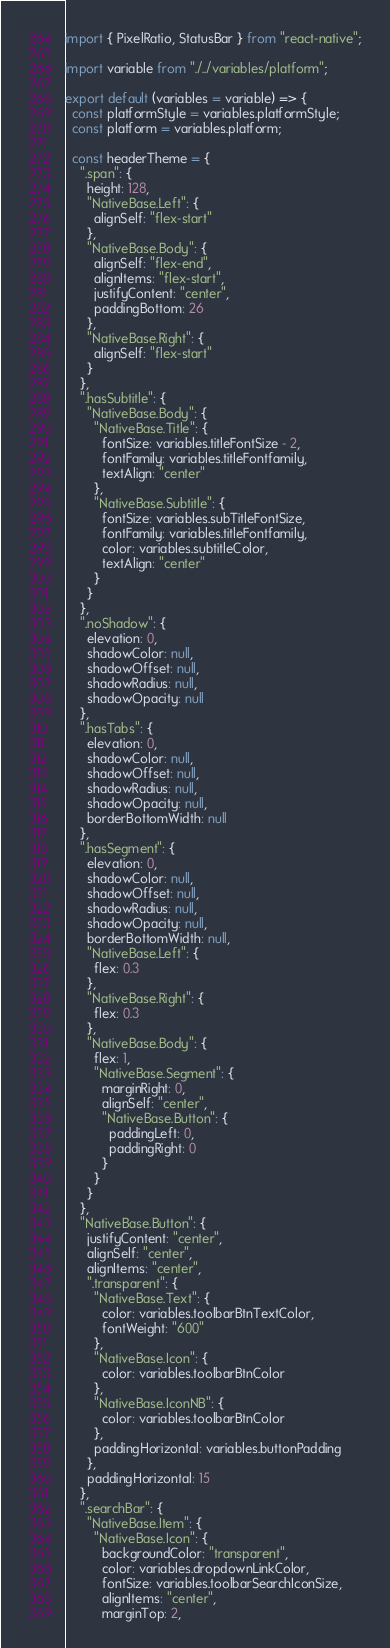Convert code to text. <code><loc_0><loc_0><loc_500><loc_500><_JavaScript_>import { PixelRatio, StatusBar } from "react-native";

import variable from "./../variables/platform";

export default (variables = variable) => {
  const platformStyle = variables.platformStyle;
  const platform = variables.platform;

  const headerTheme = {
    ".span": {
      height: 128,
      "NativeBase.Left": {
        alignSelf: "flex-start"
      },
      "NativeBase.Body": {
        alignSelf: "flex-end",
        alignItems: "flex-start",
        justifyContent: "center",
        paddingBottom: 26
      },
      "NativeBase.Right": {
        alignSelf: "flex-start"
      }
    },
    ".hasSubtitle": {
      "NativeBase.Body": {
        "NativeBase.Title": {
          fontSize: variables.titleFontSize - 2,
          fontFamily: variables.titleFontfamily,
          textAlign: "center"
        },
        "NativeBase.Subtitle": {
          fontSize: variables.subTitleFontSize,
          fontFamily: variables.titleFontfamily,
          color: variables.subtitleColor,
          textAlign: "center"
        }
      }
    },
    ".noShadow": {
      elevation: 0,
      shadowColor: null,
      shadowOffset: null,
      shadowRadius: null,
      shadowOpacity: null
    },
    ".hasTabs": {
      elevation: 0,
      shadowColor: null,
      shadowOffset: null,
      shadowRadius: null,
      shadowOpacity: null,
      borderBottomWidth: null
    },
    ".hasSegment": {
      elevation: 0,
      shadowColor: null,
      shadowOffset: null,
      shadowRadius: null,
      shadowOpacity: null,
      borderBottomWidth: null,
      "NativeBase.Left": {
        flex: 0.3
      },
      "NativeBase.Right": {
        flex: 0.3
      },
      "NativeBase.Body": {
        flex: 1,
        "NativeBase.Segment": {
          marginRight: 0,
          alignSelf: "center",
          "NativeBase.Button": {
            paddingLeft: 0,
            paddingRight: 0
          }
        }
      }
    },
    "NativeBase.Button": {
      justifyContent: "center",
      alignSelf: "center",
      alignItems: "center",
      ".transparent": {
        "NativeBase.Text": {
          color: variables.toolbarBtnTextColor,
          fontWeight: "600"
        },
        "NativeBase.Icon": {
          color: variables.toolbarBtnColor
        },
        "NativeBase.IconNB": {
          color: variables.toolbarBtnColor
        },
        paddingHorizontal: variables.buttonPadding
      },
      paddingHorizontal: 15
    },
    ".searchBar": {
      "NativeBase.Item": {
        "NativeBase.Icon": {
          backgroundColor: "transparent",
          color: variables.dropdownLinkColor,
          fontSize: variables.toolbarSearchIconSize,
          alignItems: "center",
          marginTop: 2,</code> 